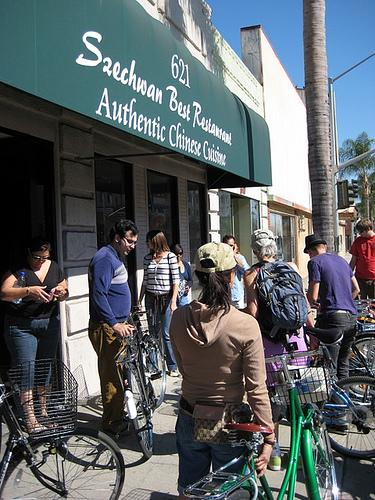What kind of food is most common in this restaurant?

Choices:
A) spicy
B) taco
C) sandwich
D) curry spicy 